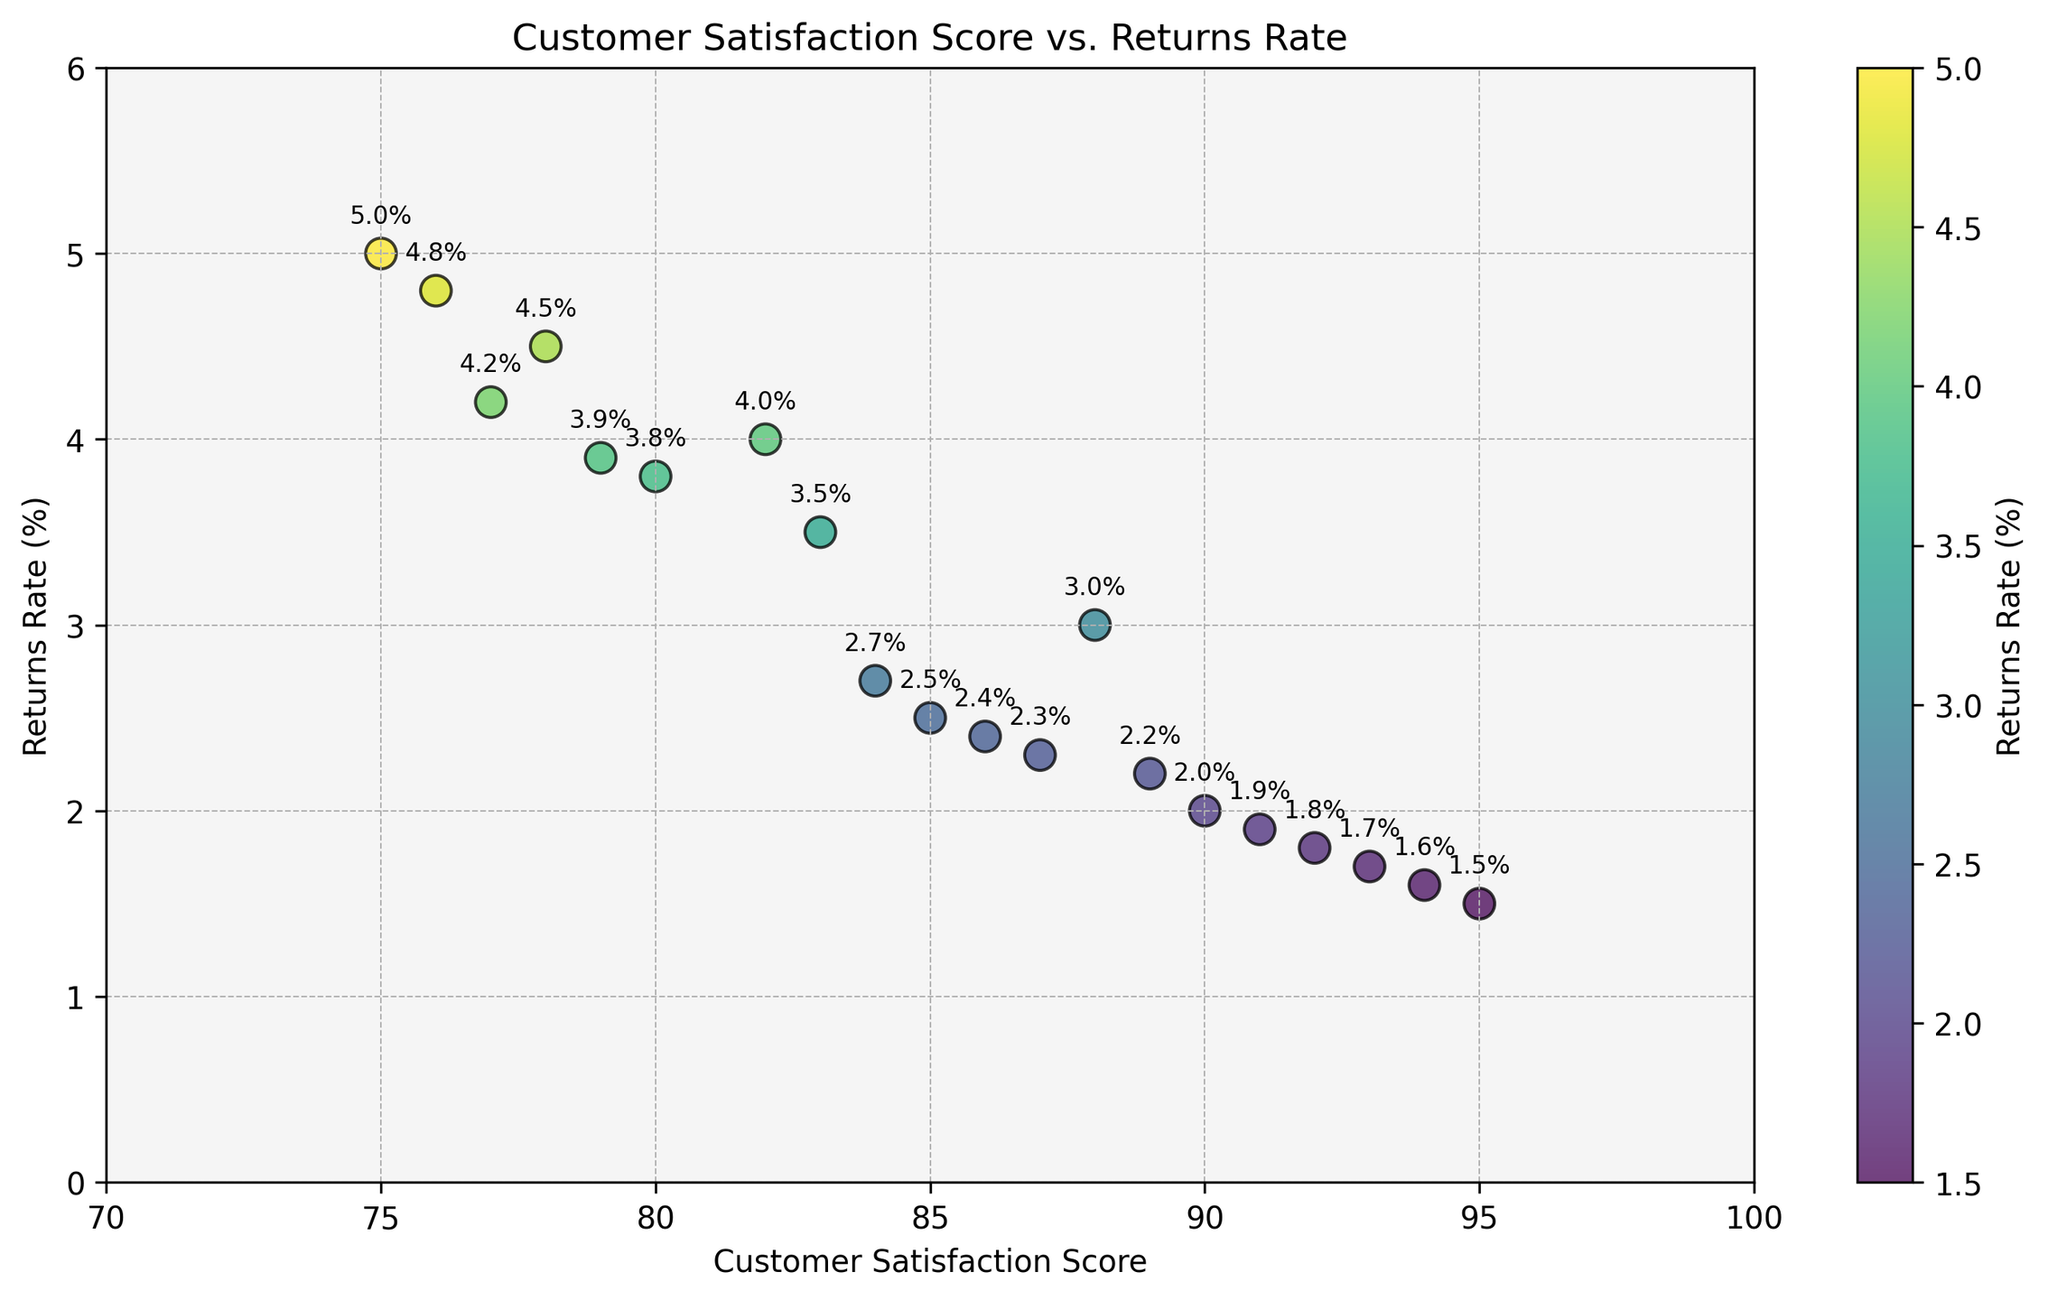What's the customer satisfaction score with the highest returns rate? The scatter plot marks each data point's customer satisfaction score along the x-axis and the returns rate along the y-axis. The highest returns rate is 5.0%, corresponding to a customer satisfaction score of 75.
Answer: 75 Which data point has the lowest returns rate, and what is its customer satisfaction score? Inspect the data points on the scatter plot, looking for the lowest y-value. The lowest returns rate is 1.5%, corresponding to a customer satisfaction score of 95.
Answer: 95 Compare the returns rate for the two data points with customer satisfaction scores of 83 and 92. Which one has a higher returns rate? Find the data points with customer satisfaction scores of 83 and 92. The returns rate for 83 is 3.5%, while for 92 it is 1.8%. Thus, the returns rate for 83 is higher.
Answer: 83 What is the average returns rate for products with customer satisfaction scores above 90? Identify the data points with customer satisfaction scores above 90: 95 (1.5%), 92 (1.8%), 91 (1.9%), 94 (1.6%), 93 (1.7%). Calculate their average: (1.5 + 1.8 + 1.9 + 1.6 + 1.7) / 5 = 1.7.
Answer: 1.7 If we group the data points into two categories based on returns rates below 3% and at or above 3%, which category has more data points? Count the data points with returns rates below 3%: {95, 90, 92, 88, 93, 89, 91, 86, 94} (9 points); and at or above 3%: {85, 82, 78, 87, 80, 75, 84, 77, 79, 76, 83} (11 points). The second category has more data points.
Answer: at or above 3% What's the difference in returns rate between customer satisfaction scores of 80 and 85? Locate the points for customer satisfaction scores of 80 and 85. Their returns rates are 3.8% and 2.5%, respectively. Calculate the difference: 3.8% - 2.5% = 1.3%.
Answer: 1.3% What is the closest returns rate to 2.0%, and what is its corresponding customer satisfaction score? Look for the data point with a returns rate nearest to 2.0%. The closest value is 2.0%, associated with a customer satisfaction score of 90.
Answer: 90 What's the returns rate of the product with customer satisfaction score 91? Locate the data point with a customer satisfaction score of 91. Its returns rate is 1.9%.
Answer: 1.9 How many products have customer satisfaction scores below 80, and what is their average returns rate? Identify data points with customer satisfaction scores below 80: {78, 75, 77, 79, 76} (5 points). Their returns rates are 4.5%, 5.0%, 4.2%, 3.9%, 4.8%. Average: (4.5 + 5.0 + 4.2 + 3.9 + 4.8) / 5 = 4.48%.
Answer: 4.48 Among the products with a customer satisfaction score of 89 and 86, which has the higher returns rate? Find the data points for customer satisfaction scores of 89 and 86. Their return rates are 2.2% and 2.4%, respectively. Thus, the product with a score of 86 has a higher returns rate.
Answer: 86 